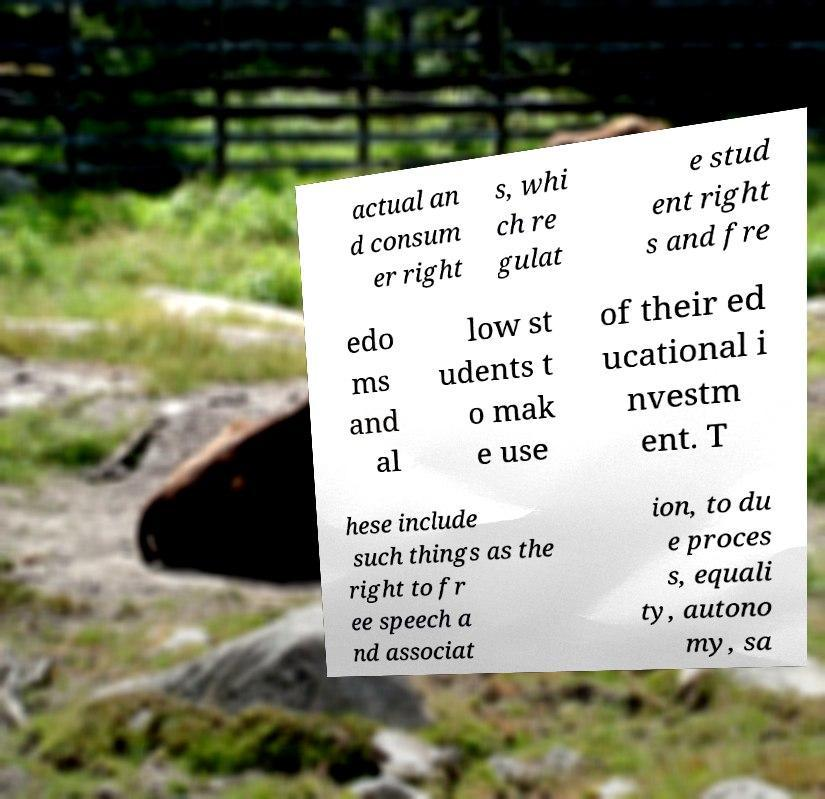For documentation purposes, I need the text within this image transcribed. Could you provide that? actual an d consum er right s, whi ch re gulat e stud ent right s and fre edo ms and al low st udents t o mak e use of their ed ucational i nvestm ent. T hese include such things as the right to fr ee speech a nd associat ion, to du e proces s, equali ty, autono my, sa 